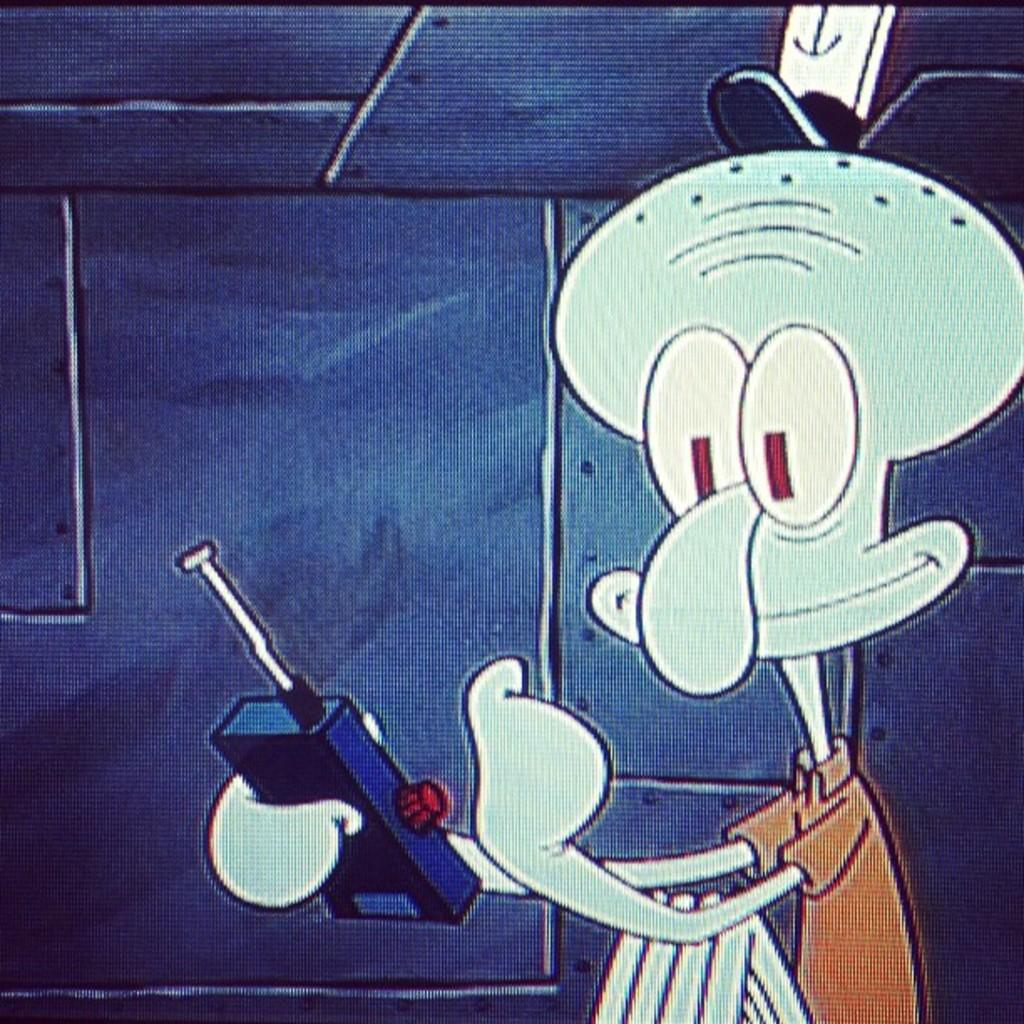What type of image is being described? The image is animated. What can be seen in the animated image? There is a cartoon toy in the image. What is the cartoon toy doing in the image? The cartoon toy is holding an object. What can be seen in the background of the image? There is a background in the image. What is present above the cartoon toy in the image? There is a roof in the image. What type of country is depicted in the background of the image? There is no country depicted in the background of the image; it is a cartoon scene with a toy and a roof. What type of calculator is being used by the donkey in the image? There is no donkey or calculator present in the image. 